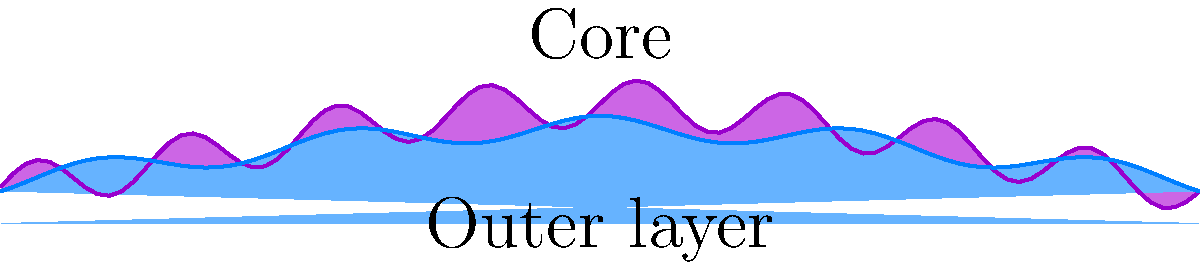In your latest sci-fi film, you're depicting a nebula's structure. Based on the illustration, which represents a cross-section of the nebula, how would you describe the density distribution from the core to the outer layers to ensure scientific accuracy in your film? To accurately depict the nebula's structure in your film, consider the following:

1. Core density: The purple region at the top represents the core. It has a higher peak and more pronounced fluctuations, indicating higher density and more complex structure.

2. Outer layer: The blue region at the bottom represents the outer layer. It has a lower peak and smoother fluctuations, suggesting lower density and less complex structure.

3. Density gradient: Moving from the core to the outer layer, we observe a gradual decrease in the overall height of the curves, representing a decrease in density.

4. Fluctuations: Both regions show some fluctuations, but they are more pronounced in the core. This suggests that while the entire nebula has some structural complexity, it's more evident in the core.

5. Edge effects: At the far left and right of the image, both curves approach zero, indicating that the nebula's density decreases significantly at its outer boundaries.

To ensure scientific accuracy, you should depict the nebula with:
1. A denser, more turbulent core
2. A less dense, smoother outer layer
3. A gradual transition between these regions
4. Overall decrease in density from the center outwards
5. Some structural complexity throughout, but more pronounced in the core
Answer: Denser, complex core transitioning to less dense, smoother outer layers with overall outward density decrease. 